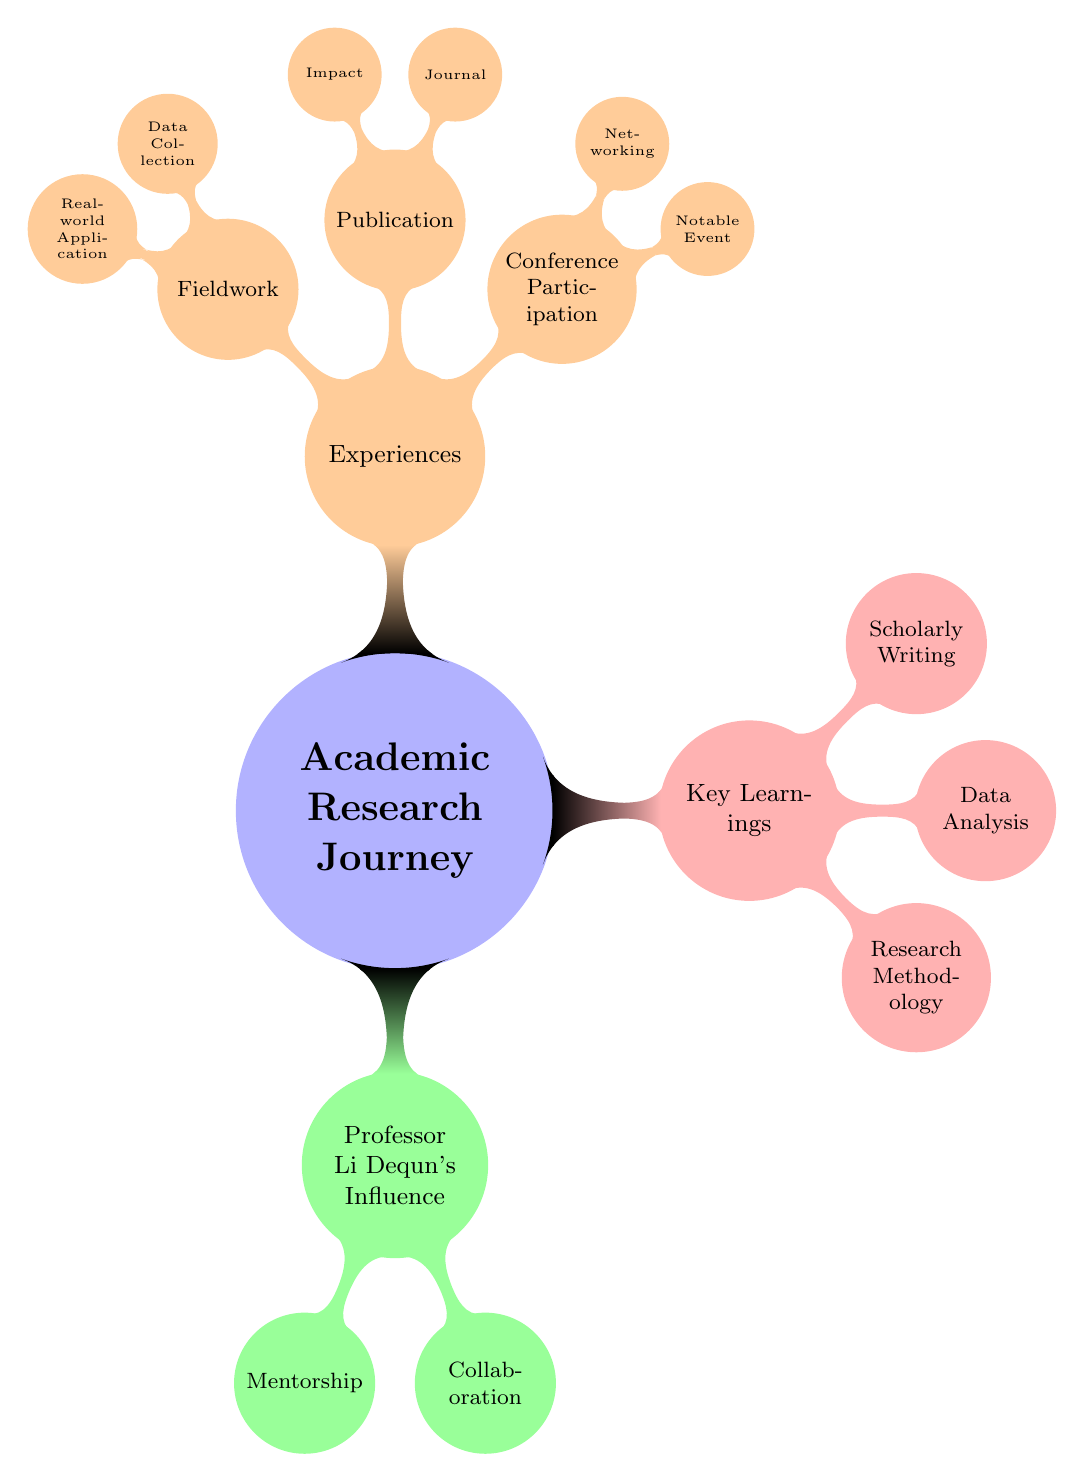What is the main focus of the diagram? The diagram is centered around the "Academic Research Journey," which is the primary node representing the overarching theme.
Answer: Academic Research Journey How many key learnings are listed in the diagram? The diagram shows three distinct learnings under the "Key Learnings" node: Research Methodology, Data Analysis, and Scholarly Writing. Therefore, counting these gives a total of three key learnings.
Answer: 3 What is one of the influences of Professor Li Dequn? The diagram lists "Mentorship" as a key aspect under the node "Professor Li Dequn's Influence," which illustrates one of his influences.
Answer: Mentorship What journal is mentioned for publication? Under the "Publication" node, the diagram specifies "Published in 'Journal of Statistical Software'" as the journal related to the experiences in academic research.
Answer: Journal of Statistical Software Which experience involves building connections with fellow researchers? The diagram identifies "Networking" under the "Conference Participation" node as the experience associated with building connections.
Answer: Networking Describe the relationship between Fieldwork and Real-world Application. The "Fieldwork" node further breaks down into "Data Collection" and "Real-world Application," indicating that fieldwork is related to and supports real-world applications of theory in practice.
Answer: Fieldwork supports Real-world Application What statistical methods did Professor Li Dequn guide in? The diagram states that Professor Li Dequn's mentorship provided guidance in "Advanced Statistical Methods," reflecting his influence on the academic research journey.
Answer: Advanced Statistical Methods How many experiences are categorized in the diagram? The "Experiences" node contains three sub-categories: Conference Participation, Publication, and Fieldwork, which means there are a total of three categorized experiences in the academic journey.
Answer: 3 What is the notable event mentioned in Conference Participation? The diagram lists "Presented Paper at ICASSP" under the node "Notable Event," indicating a specific highlight of the conference participation experience.
Answer: Presented Paper at ICASSP 